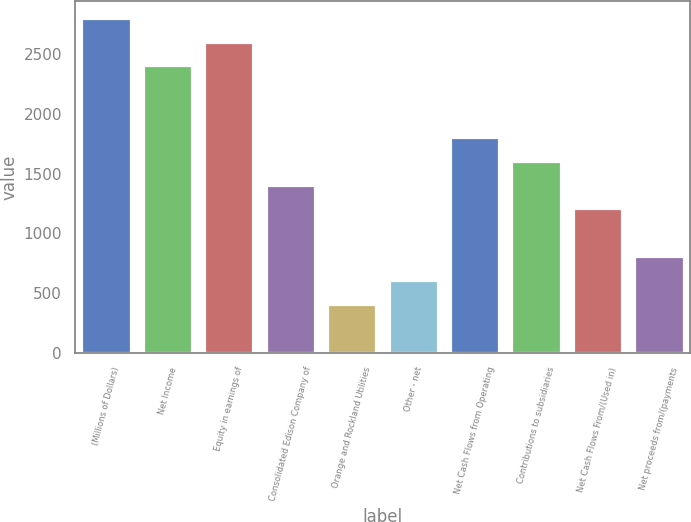Convert chart. <chart><loc_0><loc_0><loc_500><loc_500><bar_chart><fcel>(Millions of Dollars)<fcel>Net Income<fcel>Equity in earnings of<fcel>Consolidated Edison Company of<fcel>Orange and Rockland Utilities<fcel>Other - net<fcel>Net Cash Flows from Operating<fcel>Contributions to subsidiaries<fcel>Net Cash Flows From/(Used in)<fcel>Net proceeds from/(payments<nl><fcel>2804<fcel>2405<fcel>2604.5<fcel>1407.5<fcel>410<fcel>609.5<fcel>1806.5<fcel>1607<fcel>1208<fcel>809<nl></chart> 